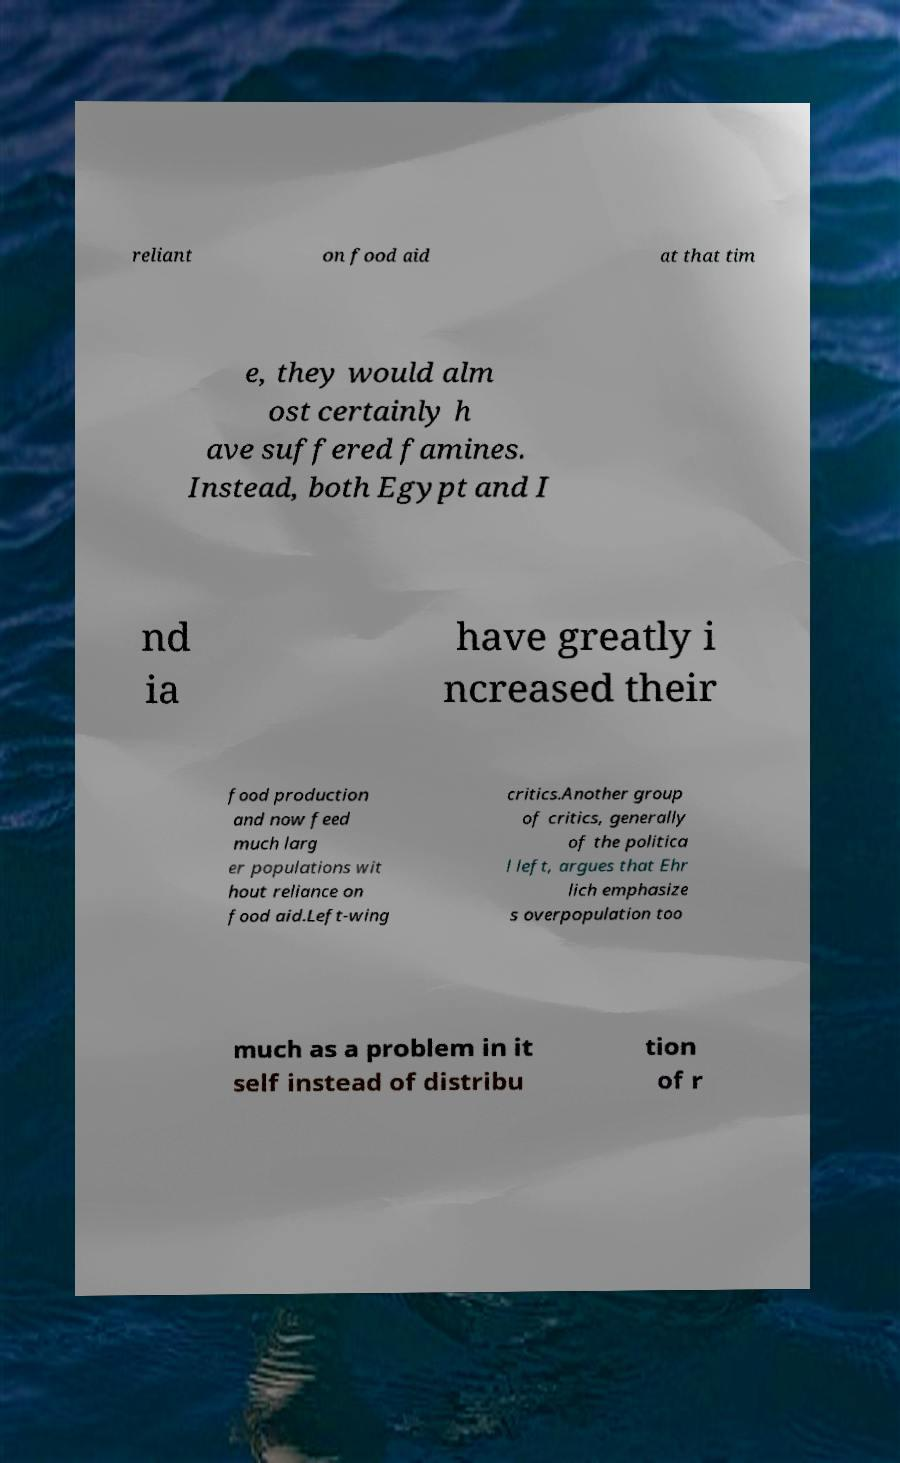Can you read and provide the text displayed in the image?This photo seems to have some interesting text. Can you extract and type it out for me? reliant on food aid at that tim e, they would alm ost certainly h ave suffered famines. Instead, both Egypt and I nd ia have greatly i ncreased their food production and now feed much larg er populations wit hout reliance on food aid.Left-wing critics.Another group of critics, generally of the politica l left, argues that Ehr lich emphasize s overpopulation too much as a problem in it self instead of distribu tion of r 